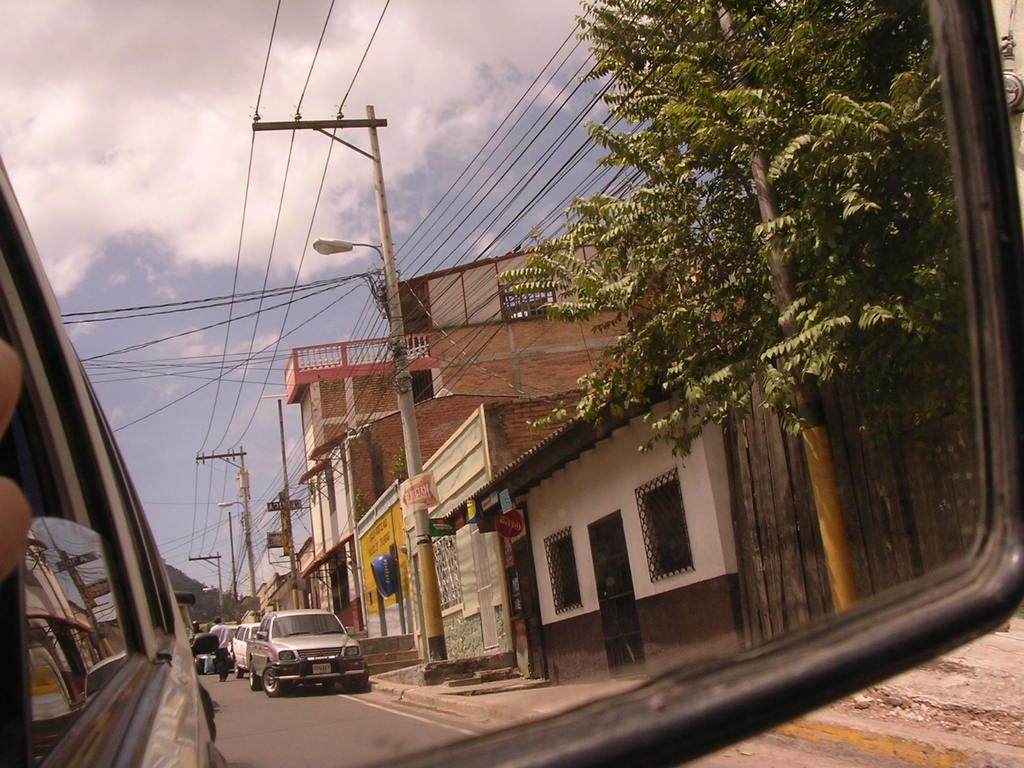What is the main subject of the image? There is a person in the image. What can be seen on the road in the image? There are vehicles on the road in the image. What type of structures are visible in the image? There are buildings with windows in the image. What type of vegetation is present in the image? Trees are present in the image. What type of infrastructure can be seen in the image? Wires and poles are visible in the image. What is visible in the background of the image? The sky with clouds is visible in the background of the image. What type of pump is visible in the image? There is no pump present in the image. What role does society play in the image? The image does not depict a specific society or social context, so it is not possible to determine the role of society in the image. 